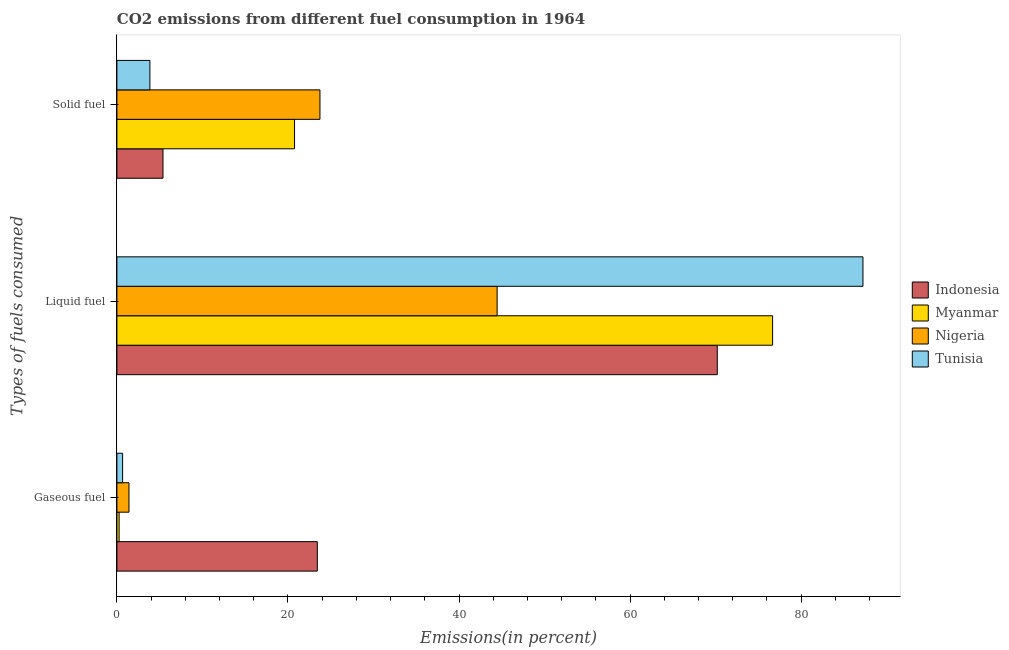Are the number of bars on each tick of the Y-axis equal?
Offer a very short reply. Yes. What is the label of the 3rd group of bars from the top?
Give a very brief answer. Gaseous fuel. What is the percentage of solid fuel emission in Tunisia?
Provide a short and direct response. 3.86. Across all countries, what is the maximum percentage of solid fuel emission?
Give a very brief answer. 23.74. Across all countries, what is the minimum percentage of gaseous fuel emission?
Make the answer very short. 0.26. In which country was the percentage of solid fuel emission maximum?
Your answer should be compact. Nigeria. In which country was the percentage of solid fuel emission minimum?
Ensure brevity in your answer.  Tunisia. What is the total percentage of gaseous fuel emission in the graph?
Ensure brevity in your answer.  25.76. What is the difference between the percentage of liquid fuel emission in Myanmar and that in Tunisia?
Your answer should be very brief. -10.57. What is the difference between the percentage of gaseous fuel emission in Tunisia and the percentage of liquid fuel emission in Indonesia?
Offer a terse response. -69.53. What is the average percentage of gaseous fuel emission per country?
Your answer should be compact. 6.44. What is the difference between the percentage of gaseous fuel emission and percentage of liquid fuel emission in Myanmar?
Your answer should be compact. -76.41. In how many countries, is the percentage of liquid fuel emission greater than 60 %?
Make the answer very short. 3. What is the ratio of the percentage of liquid fuel emission in Nigeria to that in Myanmar?
Give a very brief answer. 0.58. Is the percentage of solid fuel emission in Indonesia less than that in Myanmar?
Offer a terse response. Yes. Is the difference between the percentage of solid fuel emission in Tunisia and Nigeria greater than the difference between the percentage of gaseous fuel emission in Tunisia and Nigeria?
Your response must be concise. No. What is the difference between the highest and the second highest percentage of solid fuel emission?
Keep it short and to the point. 2.97. What is the difference between the highest and the lowest percentage of liquid fuel emission?
Your answer should be compact. 42.78. In how many countries, is the percentage of liquid fuel emission greater than the average percentage of liquid fuel emission taken over all countries?
Provide a short and direct response. 3. Is the sum of the percentage of liquid fuel emission in Nigeria and Indonesia greater than the maximum percentage of solid fuel emission across all countries?
Offer a very short reply. Yes. Is it the case that in every country, the sum of the percentage of gaseous fuel emission and percentage of liquid fuel emission is greater than the percentage of solid fuel emission?
Provide a short and direct response. Yes. Are all the bars in the graph horizontal?
Offer a very short reply. Yes. What is the difference between two consecutive major ticks on the X-axis?
Your response must be concise. 20. Are the values on the major ticks of X-axis written in scientific E-notation?
Your answer should be compact. No. Does the graph contain any zero values?
Make the answer very short. No. Does the graph contain grids?
Your response must be concise. No. How many legend labels are there?
Your answer should be compact. 4. What is the title of the graph?
Your answer should be compact. CO2 emissions from different fuel consumption in 1964. What is the label or title of the X-axis?
Provide a succinct answer. Emissions(in percent). What is the label or title of the Y-axis?
Provide a succinct answer. Types of fuels consumed. What is the Emissions(in percent) in Indonesia in Gaseous fuel?
Provide a short and direct response. 23.43. What is the Emissions(in percent) of Myanmar in Gaseous fuel?
Your response must be concise. 0.26. What is the Emissions(in percent) of Nigeria in Gaseous fuel?
Give a very brief answer. 1.41. What is the Emissions(in percent) of Tunisia in Gaseous fuel?
Ensure brevity in your answer.  0.66. What is the Emissions(in percent) in Indonesia in Liquid fuel?
Give a very brief answer. 70.2. What is the Emissions(in percent) in Myanmar in Liquid fuel?
Offer a very short reply. 76.67. What is the Emissions(in percent) of Nigeria in Liquid fuel?
Give a very brief answer. 44.46. What is the Emissions(in percent) of Tunisia in Liquid fuel?
Provide a short and direct response. 87.23. What is the Emissions(in percent) in Indonesia in Solid fuel?
Your answer should be very brief. 5.39. What is the Emissions(in percent) in Myanmar in Solid fuel?
Make the answer very short. 20.77. What is the Emissions(in percent) of Nigeria in Solid fuel?
Offer a terse response. 23.74. What is the Emissions(in percent) of Tunisia in Solid fuel?
Provide a succinct answer. 3.86. Across all Types of fuels consumed, what is the maximum Emissions(in percent) in Indonesia?
Your answer should be compact. 70.2. Across all Types of fuels consumed, what is the maximum Emissions(in percent) of Myanmar?
Give a very brief answer. 76.67. Across all Types of fuels consumed, what is the maximum Emissions(in percent) in Nigeria?
Offer a very short reply. 44.46. Across all Types of fuels consumed, what is the maximum Emissions(in percent) in Tunisia?
Keep it short and to the point. 87.23. Across all Types of fuels consumed, what is the minimum Emissions(in percent) of Indonesia?
Make the answer very short. 5.39. Across all Types of fuels consumed, what is the minimum Emissions(in percent) in Myanmar?
Offer a very short reply. 0.26. Across all Types of fuels consumed, what is the minimum Emissions(in percent) in Nigeria?
Your answer should be very brief. 1.41. Across all Types of fuels consumed, what is the minimum Emissions(in percent) in Tunisia?
Ensure brevity in your answer.  0.66. What is the total Emissions(in percent) in Indonesia in the graph?
Give a very brief answer. 99.02. What is the total Emissions(in percent) of Myanmar in the graph?
Ensure brevity in your answer.  97.69. What is the total Emissions(in percent) in Nigeria in the graph?
Offer a terse response. 69.61. What is the total Emissions(in percent) in Tunisia in the graph?
Ensure brevity in your answer.  91.76. What is the difference between the Emissions(in percent) of Indonesia in Gaseous fuel and that in Liquid fuel?
Give a very brief answer. -46.77. What is the difference between the Emissions(in percent) in Myanmar in Gaseous fuel and that in Liquid fuel?
Offer a terse response. -76.41. What is the difference between the Emissions(in percent) in Nigeria in Gaseous fuel and that in Liquid fuel?
Make the answer very short. -43.04. What is the difference between the Emissions(in percent) in Tunisia in Gaseous fuel and that in Liquid fuel?
Your answer should be very brief. -86.57. What is the difference between the Emissions(in percent) in Indonesia in Gaseous fuel and that in Solid fuel?
Ensure brevity in your answer.  18.04. What is the difference between the Emissions(in percent) of Myanmar in Gaseous fuel and that in Solid fuel?
Keep it short and to the point. -20.51. What is the difference between the Emissions(in percent) of Nigeria in Gaseous fuel and that in Solid fuel?
Ensure brevity in your answer.  -22.33. What is the difference between the Emissions(in percent) in Tunisia in Gaseous fuel and that in Solid fuel?
Make the answer very short. -3.19. What is the difference between the Emissions(in percent) of Indonesia in Liquid fuel and that in Solid fuel?
Offer a terse response. 64.81. What is the difference between the Emissions(in percent) of Myanmar in Liquid fuel and that in Solid fuel?
Give a very brief answer. 55.9. What is the difference between the Emissions(in percent) of Nigeria in Liquid fuel and that in Solid fuel?
Provide a succinct answer. 20.72. What is the difference between the Emissions(in percent) in Tunisia in Liquid fuel and that in Solid fuel?
Your response must be concise. 83.38. What is the difference between the Emissions(in percent) of Indonesia in Gaseous fuel and the Emissions(in percent) of Myanmar in Liquid fuel?
Your answer should be very brief. -53.23. What is the difference between the Emissions(in percent) in Indonesia in Gaseous fuel and the Emissions(in percent) in Nigeria in Liquid fuel?
Give a very brief answer. -21.02. What is the difference between the Emissions(in percent) of Indonesia in Gaseous fuel and the Emissions(in percent) of Tunisia in Liquid fuel?
Provide a succinct answer. -63.8. What is the difference between the Emissions(in percent) in Myanmar in Gaseous fuel and the Emissions(in percent) in Nigeria in Liquid fuel?
Keep it short and to the point. -44.2. What is the difference between the Emissions(in percent) of Myanmar in Gaseous fuel and the Emissions(in percent) of Tunisia in Liquid fuel?
Keep it short and to the point. -86.98. What is the difference between the Emissions(in percent) of Nigeria in Gaseous fuel and the Emissions(in percent) of Tunisia in Liquid fuel?
Offer a terse response. -85.82. What is the difference between the Emissions(in percent) of Indonesia in Gaseous fuel and the Emissions(in percent) of Myanmar in Solid fuel?
Make the answer very short. 2.66. What is the difference between the Emissions(in percent) in Indonesia in Gaseous fuel and the Emissions(in percent) in Nigeria in Solid fuel?
Your answer should be very brief. -0.31. What is the difference between the Emissions(in percent) in Indonesia in Gaseous fuel and the Emissions(in percent) in Tunisia in Solid fuel?
Provide a short and direct response. 19.58. What is the difference between the Emissions(in percent) of Myanmar in Gaseous fuel and the Emissions(in percent) of Nigeria in Solid fuel?
Ensure brevity in your answer.  -23.48. What is the difference between the Emissions(in percent) of Nigeria in Gaseous fuel and the Emissions(in percent) of Tunisia in Solid fuel?
Provide a succinct answer. -2.45. What is the difference between the Emissions(in percent) in Indonesia in Liquid fuel and the Emissions(in percent) in Myanmar in Solid fuel?
Provide a succinct answer. 49.43. What is the difference between the Emissions(in percent) of Indonesia in Liquid fuel and the Emissions(in percent) of Nigeria in Solid fuel?
Keep it short and to the point. 46.46. What is the difference between the Emissions(in percent) in Indonesia in Liquid fuel and the Emissions(in percent) in Tunisia in Solid fuel?
Your response must be concise. 66.34. What is the difference between the Emissions(in percent) of Myanmar in Liquid fuel and the Emissions(in percent) of Nigeria in Solid fuel?
Provide a short and direct response. 52.93. What is the difference between the Emissions(in percent) of Myanmar in Liquid fuel and the Emissions(in percent) of Tunisia in Solid fuel?
Provide a short and direct response. 72.81. What is the difference between the Emissions(in percent) of Nigeria in Liquid fuel and the Emissions(in percent) of Tunisia in Solid fuel?
Offer a terse response. 40.6. What is the average Emissions(in percent) in Indonesia per Types of fuels consumed?
Give a very brief answer. 33.01. What is the average Emissions(in percent) in Myanmar per Types of fuels consumed?
Ensure brevity in your answer.  32.56. What is the average Emissions(in percent) in Nigeria per Types of fuels consumed?
Offer a terse response. 23.2. What is the average Emissions(in percent) of Tunisia per Types of fuels consumed?
Provide a succinct answer. 30.59. What is the difference between the Emissions(in percent) in Indonesia and Emissions(in percent) in Myanmar in Gaseous fuel?
Your response must be concise. 23.18. What is the difference between the Emissions(in percent) of Indonesia and Emissions(in percent) of Nigeria in Gaseous fuel?
Give a very brief answer. 22.02. What is the difference between the Emissions(in percent) in Indonesia and Emissions(in percent) in Tunisia in Gaseous fuel?
Keep it short and to the point. 22.77. What is the difference between the Emissions(in percent) in Myanmar and Emissions(in percent) in Nigeria in Gaseous fuel?
Give a very brief answer. -1.15. What is the difference between the Emissions(in percent) in Myanmar and Emissions(in percent) in Tunisia in Gaseous fuel?
Your answer should be very brief. -0.41. What is the difference between the Emissions(in percent) in Nigeria and Emissions(in percent) in Tunisia in Gaseous fuel?
Ensure brevity in your answer.  0.75. What is the difference between the Emissions(in percent) in Indonesia and Emissions(in percent) in Myanmar in Liquid fuel?
Provide a succinct answer. -6.47. What is the difference between the Emissions(in percent) of Indonesia and Emissions(in percent) of Nigeria in Liquid fuel?
Offer a very short reply. 25.74. What is the difference between the Emissions(in percent) of Indonesia and Emissions(in percent) of Tunisia in Liquid fuel?
Your response must be concise. -17.04. What is the difference between the Emissions(in percent) of Myanmar and Emissions(in percent) of Nigeria in Liquid fuel?
Provide a succinct answer. 32.21. What is the difference between the Emissions(in percent) in Myanmar and Emissions(in percent) in Tunisia in Liquid fuel?
Ensure brevity in your answer.  -10.57. What is the difference between the Emissions(in percent) in Nigeria and Emissions(in percent) in Tunisia in Liquid fuel?
Offer a very short reply. -42.78. What is the difference between the Emissions(in percent) in Indonesia and Emissions(in percent) in Myanmar in Solid fuel?
Keep it short and to the point. -15.38. What is the difference between the Emissions(in percent) of Indonesia and Emissions(in percent) of Nigeria in Solid fuel?
Make the answer very short. -18.35. What is the difference between the Emissions(in percent) of Indonesia and Emissions(in percent) of Tunisia in Solid fuel?
Keep it short and to the point. 1.53. What is the difference between the Emissions(in percent) of Myanmar and Emissions(in percent) of Nigeria in Solid fuel?
Give a very brief answer. -2.97. What is the difference between the Emissions(in percent) in Myanmar and Emissions(in percent) in Tunisia in Solid fuel?
Your answer should be very brief. 16.91. What is the difference between the Emissions(in percent) in Nigeria and Emissions(in percent) in Tunisia in Solid fuel?
Offer a terse response. 19.88. What is the ratio of the Emissions(in percent) in Indonesia in Gaseous fuel to that in Liquid fuel?
Make the answer very short. 0.33. What is the ratio of the Emissions(in percent) in Myanmar in Gaseous fuel to that in Liquid fuel?
Offer a terse response. 0. What is the ratio of the Emissions(in percent) of Nigeria in Gaseous fuel to that in Liquid fuel?
Keep it short and to the point. 0.03. What is the ratio of the Emissions(in percent) in Tunisia in Gaseous fuel to that in Liquid fuel?
Give a very brief answer. 0.01. What is the ratio of the Emissions(in percent) in Indonesia in Gaseous fuel to that in Solid fuel?
Offer a terse response. 4.35. What is the ratio of the Emissions(in percent) of Myanmar in Gaseous fuel to that in Solid fuel?
Make the answer very short. 0.01. What is the ratio of the Emissions(in percent) of Nigeria in Gaseous fuel to that in Solid fuel?
Keep it short and to the point. 0.06. What is the ratio of the Emissions(in percent) in Tunisia in Gaseous fuel to that in Solid fuel?
Provide a short and direct response. 0.17. What is the ratio of the Emissions(in percent) of Indonesia in Liquid fuel to that in Solid fuel?
Make the answer very short. 13.03. What is the ratio of the Emissions(in percent) in Myanmar in Liquid fuel to that in Solid fuel?
Ensure brevity in your answer.  3.69. What is the ratio of the Emissions(in percent) in Nigeria in Liquid fuel to that in Solid fuel?
Ensure brevity in your answer.  1.87. What is the ratio of the Emissions(in percent) in Tunisia in Liquid fuel to that in Solid fuel?
Give a very brief answer. 22.62. What is the difference between the highest and the second highest Emissions(in percent) of Indonesia?
Ensure brevity in your answer.  46.77. What is the difference between the highest and the second highest Emissions(in percent) in Myanmar?
Make the answer very short. 55.9. What is the difference between the highest and the second highest Emissions(in percent) of Nigeria?
Ensure brevity in your answer.  20.72. What is the difference between the highest and the second highest Emissions(in percent) in Tunisia?
Offer a very short reply. 83.38. What is the difference between the highest and the lowest Emissions(in percent) of Indonesia?
Provide a succinct answer. 64.81. What is the difference between the highest and the lowest Emissions(in percent) in Myanmar?
Offer a very short reply. 76.41. What is the difference between the highest and the lowest Emissions(in percent) of Nigeria?
Your answer should be compact. 43.04. What is the difference between the highest and the lowest Emissions(in percent) of Tunisia?
Offer a terse response. 86.57. 